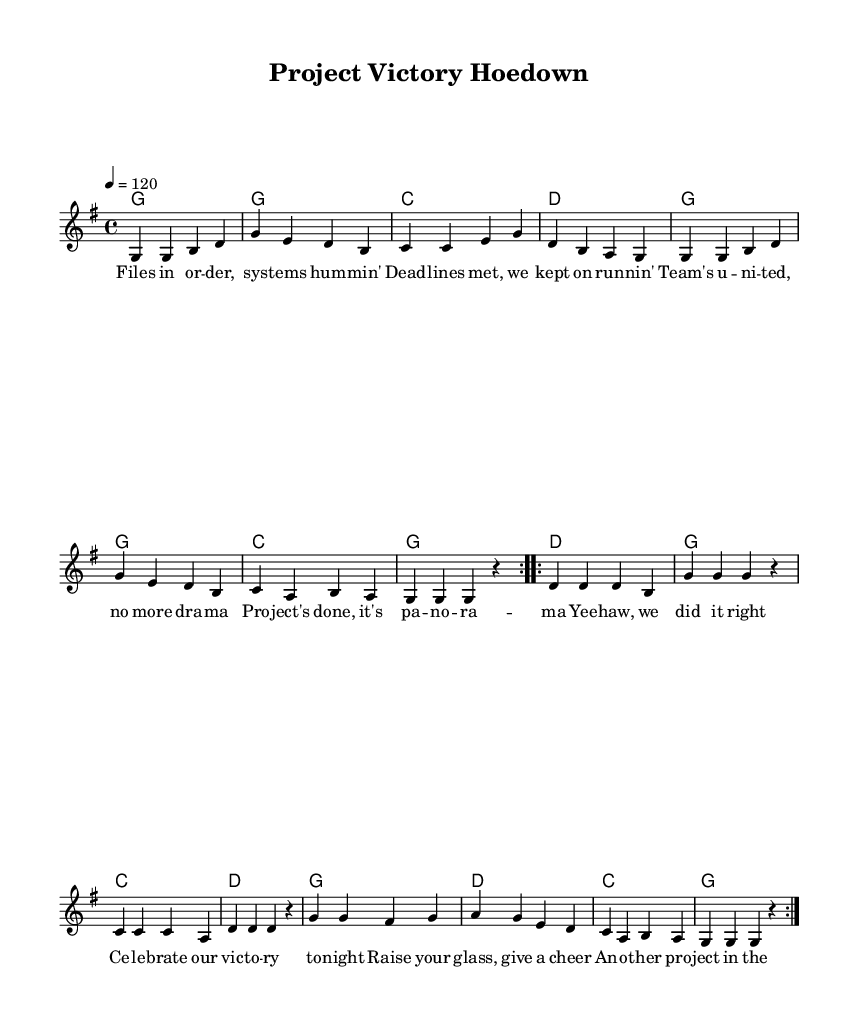What is the key signature of this music? The key signature is G major, which has one sharp (F#). This can be identified by looking at the beginning of the staff where the sharps are indicated.
Answer: G major What is the time signature of this music? The time signature is 4/4, meaning there are four beats in each measure. This is displayed at the beginning of the score next to the key signature.
Answer: 4/4 What is the tempo marking of this music? The tempo marking is 120 beats per minute, indicated by the metronome marking "4 = 120" at the beginning of the score.
Answer: 120 How many times is the first section repeated? The first section, marked by the "volta", is repeated twice as evident by the repeat signs. This can be understood by observing the markings at the beginning of that section.
Answer: 2 What type of song structure does this piece follow? This piece follows a verse-chorus structure, typical in country music. The sections described are labeled as "verseOne" and "chorus" indicating this layout.
Answer: Verse-Chorus What is the theme of the lyrics in the song? The theme revolves around celebrating a completed project and teamwork, as expressed in the lyrics that mention files, deadlines, and victory celebrations. This theme aligns with the context of project management.
Answer: Celebration 